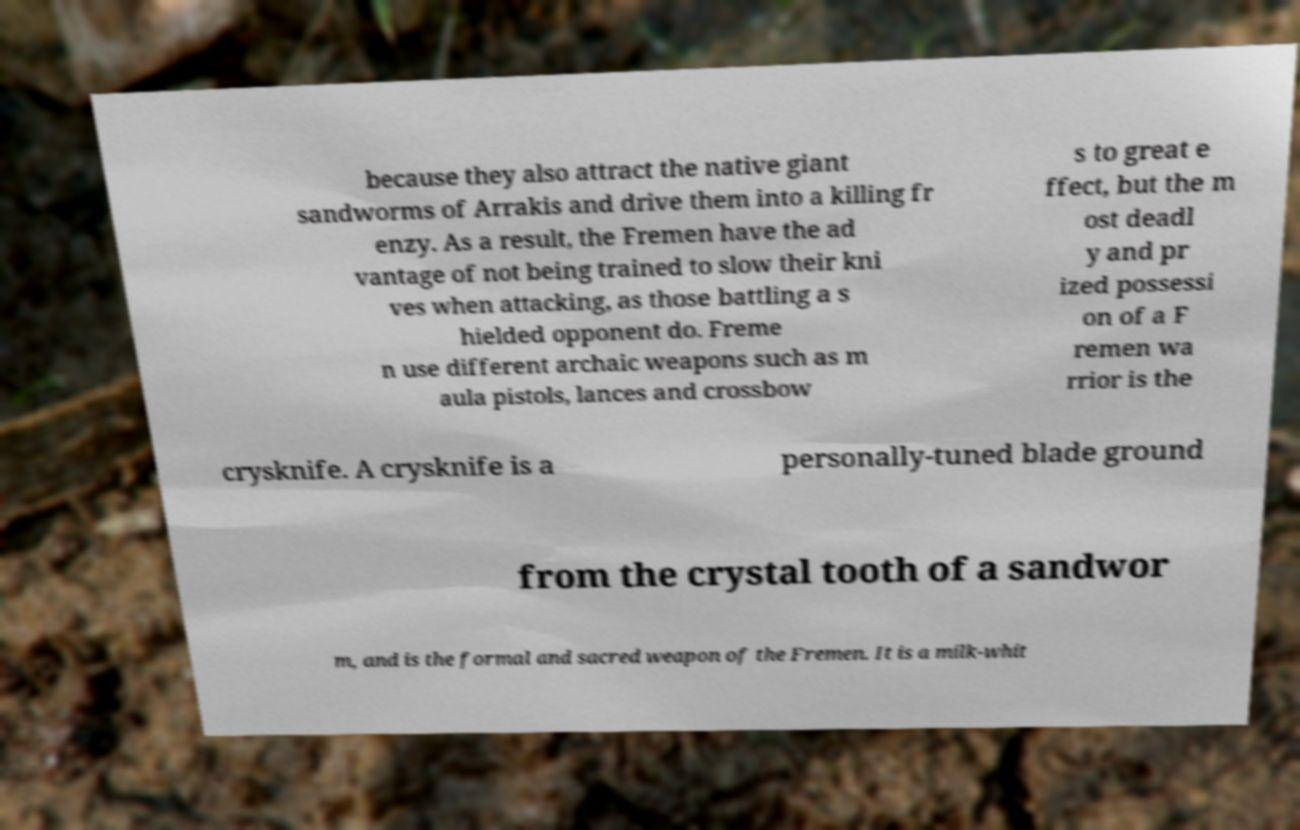Could you assist in decoding the text presented in this image and type it out clearly? because they also attract the native giant sandworms of Arrakis and drive them into a killing fr enzy. As a result, the Fremen have the ad vantage of not being trained to slow their kni ves when attacking, as those battling a s hielded opponent do. Freme n use different archaic weapons such as m aula pistols, lances and crossbow s to great e ffect, but the m ost deadl y and pr ized possessi on of a F remen wa rrior is the crysknife. A crysknife is a personally-tuned blade ground from the crystal tooth of a sandwor m, and is the formal and sacred weapon of the Fremen. It is a milk-whit 